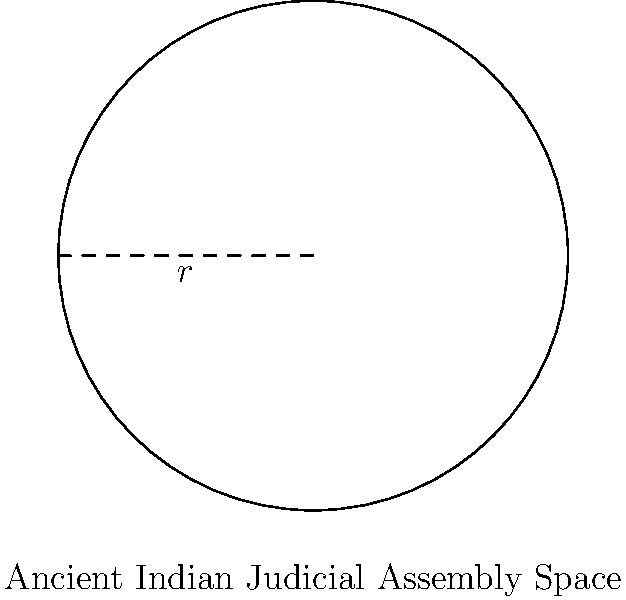In ancient Indian judicial proceedings, a circular outdoor assembly space was used for hearings. If the radius of this space was 30 meters, what was the total area available for the assembly? Round your answer to the nearest square meter. To solve this problem, we need to follow these steps:

1. Recall the formula for the area of a circle:
   $$A = \pi r^2$$
   Where $A$ is the area and $r$ is the radius.

2. We are given that the radius is 30 meters. Let's substitute this into our formula:
   $$A = \pi (30)^2$$

3. Now, let's calculate:
   $$A = \pi (900)$$
   $$A = 2827.4333... \text{ square meters}$$

4. Rounding to the nearest square meter:
   $$A \approx 2827 \text{ square meters}$$

This calculation gives us the total area of the ancient Indian judicial assembly space, providing insight into the scale of these historical proceedings.
Answer: 2827 square meters 